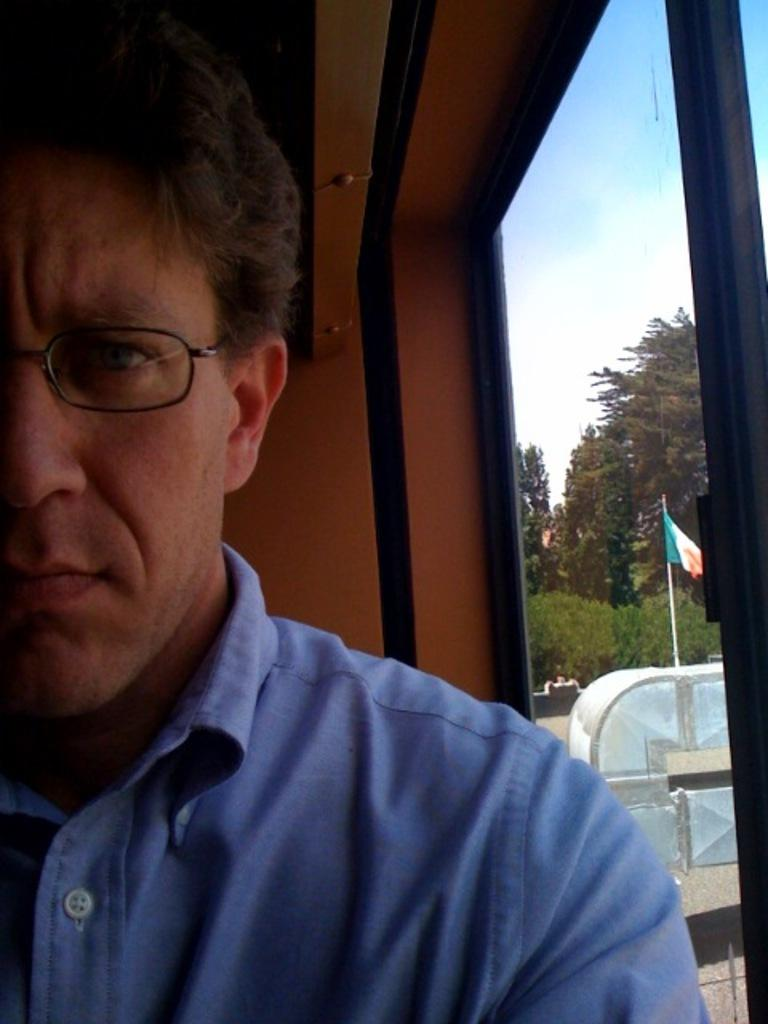Who is present in the image? There is a man in the image. What is the man wearing? The man is wearing a blue shirt. What can be seen on the left side of the image? There is a window on the left side of the image. What is visible through the window? Trees, a flag pole, and clouds are visible through the window. What type of art can be seen hanging on the wall in the image? There is no art visible on the wall in the image. How many balls are being juggled by the man in the image? There are no balls or juggling activity present in the image. 